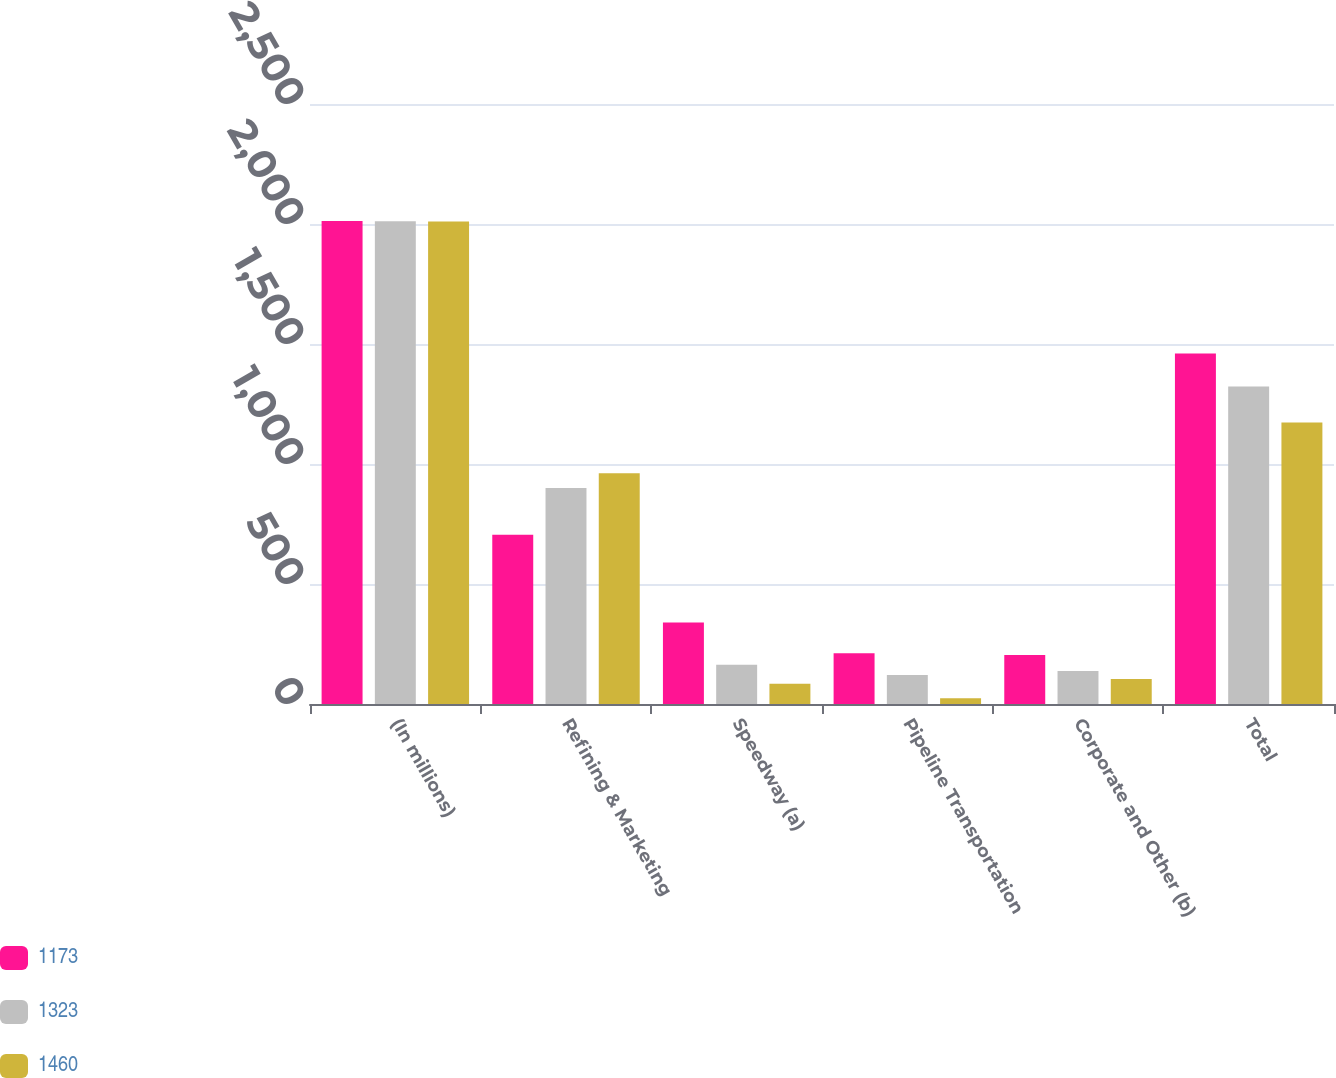Convert chart. <chart><loc_0><loc_0><loc_500><loc_500><stacked_bar_chart><ecel><fcel>(In millions)<fcel>Refining & Marketing<fcel>Speedway (a)<fcel>Pipeline Transportation<fcel>Corporate and Other (b)<fcel>Total<nl><fcel>1173<fcel>2012<fcel>705<fcel>340<fcel>211<fcel>204<fcel>1460<nl><fcel>1323<fcel>2011<fcel>900<fcel>164<fcel>121<fcel>138<fcel>1323<nl><fcel>1460<fcel>2010<fcel>961<fcel>84<fcel>24<fcel>104<fcel>1173<nl></chart> 